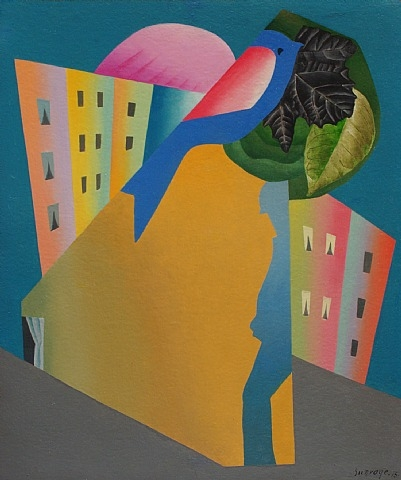How do the architectural elements contribute to the overall impact of the artwork? The architectural elements, depicted in pale yellow and orange, add a layer of complexity to the artwork. Their geometric shapes and window-like features might represent the organized, repetitive structures of urban life, contrasting sharply with the organic, flowing forms of the bird and leaf. This juxtaposition could be exploring the balance—or tension—between man-made environments and natural elements, urging viewers to reflect on their relationship with the surrounding world. 